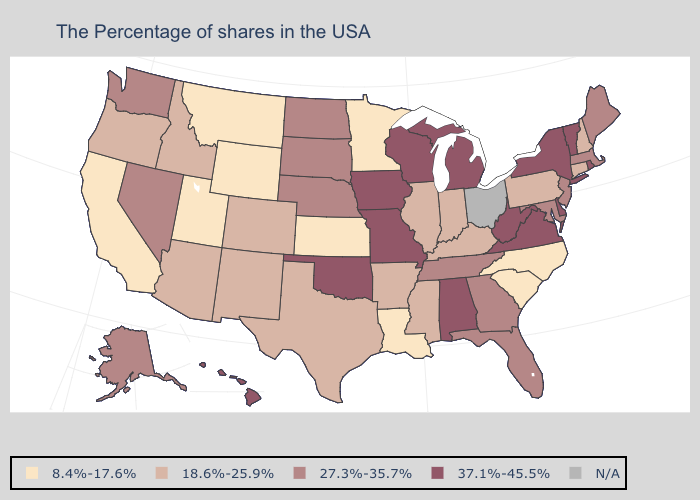Is the legend a continuous bar?
Write a very short answer. No. Does Wyoming have the lowest value in the USA?
Give a very brief answer. Yes. Does the map have missing data?
Concise answer only. Yes. What is the highest value in the MidWest ?
Short answer required. 37.1%-45.5%. Does the map have missing data?
Quick response, please. Yes. Name the states that have a value in the range 18.6%-25.9%?
Answer briefly. New Hampshire, Connecticut, Pennsylvania, Kentucky, Indiana, Illinois, Mississippi, Arkansas, Texas, Colorado, New Mexico, Arizona, Idaho, Oregon. Does Utah have the highest value in the USA?
Short answer required. No. Name the states that have a value in the range 8.4%-17.6%?
Short answer required. North Carolina, South Carolina, Louisiana, Minnesota, Kansas, Wyoming, Utah, Montana, California. Which states have the lowest value in the West?
Quick response, please. Wyoming, Utah, Montana, California. Does Hawaii have the highest value in the USA?
Be succinct. Yes. What is the value of Louisiana?
Write a very short answer. 8.4%-17.6%. Is the legend a continuous bar?
Be succinct. No. What is the value of Idaho?
Quick response, please. 18.6%-25.9%. What is the value of Missouri?
Concise answer only. 37.1%-45.5%. 